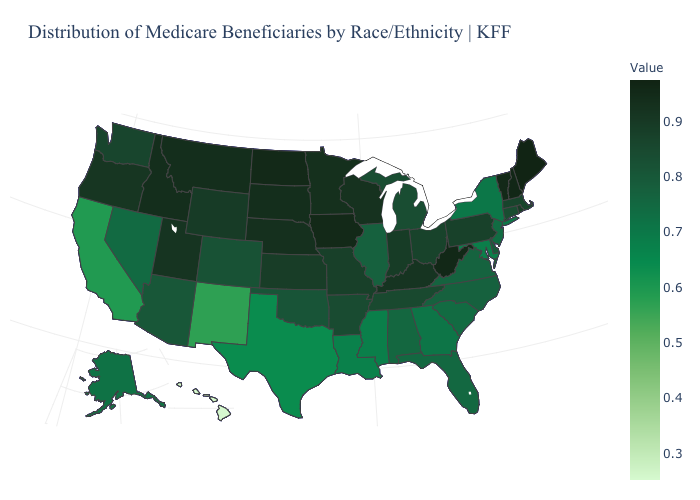Does the map have missing data?
Keep it brief. No. Which states hav the highest value in the South?
Write a very short answer. West Virginia. Is the legend a continuous bar?
Short answer required. Yes. Which states have the highest value in the USA?
Be succinct. Maine. Which states have the highest value in the USA?
Give a very brief answer. Maine. Does Missouri have a lower value than Texas?
Write a very short answer. No. 